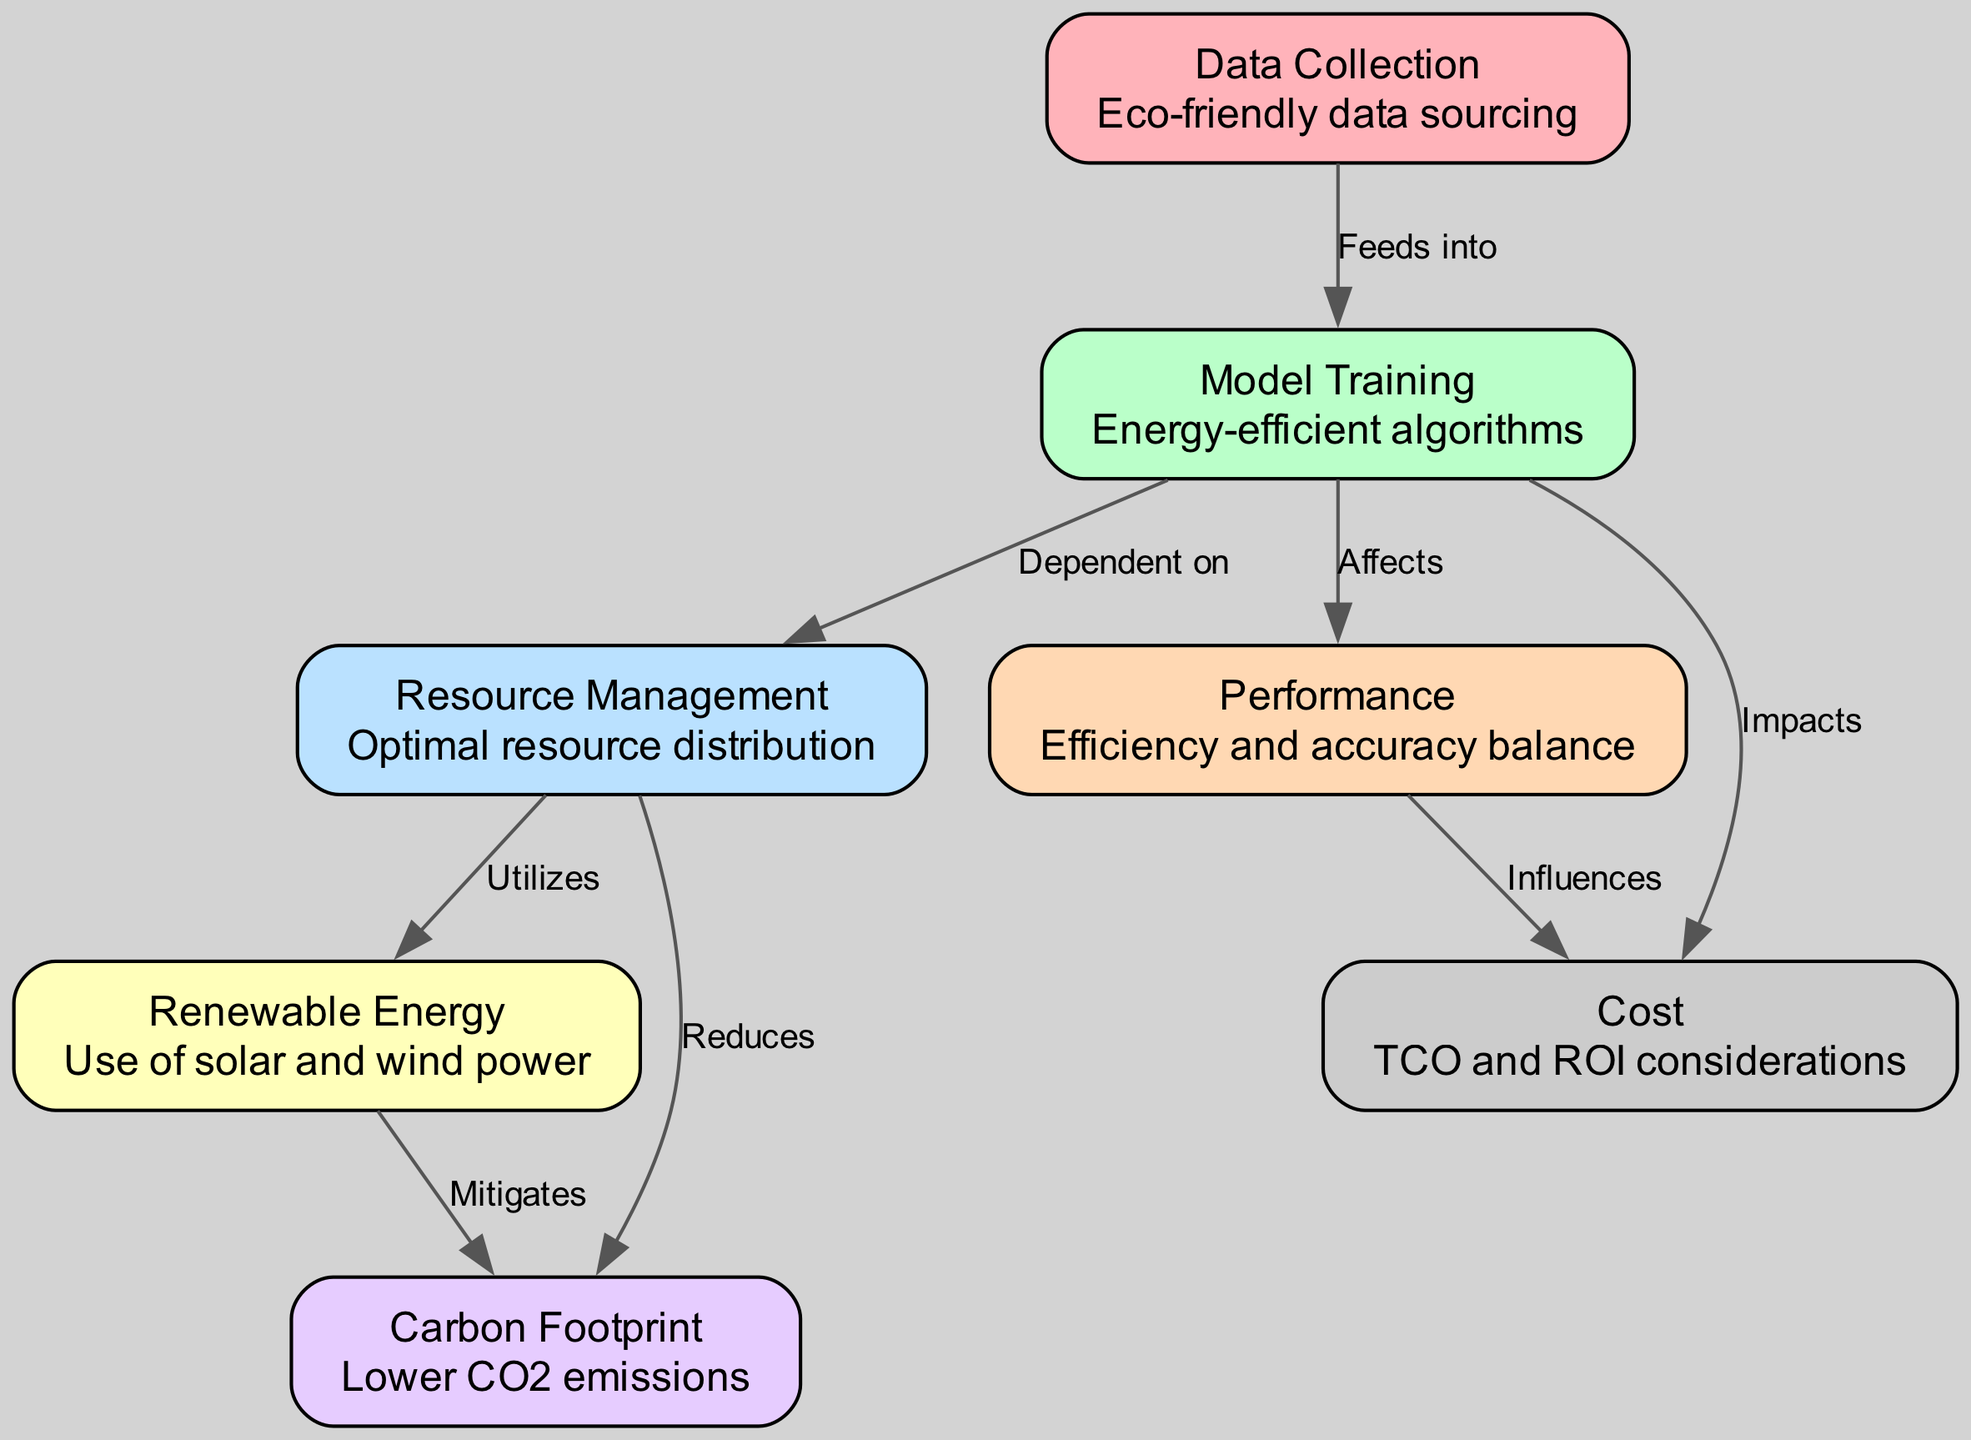What are the main topics covered in the diagram? The diagram lists seven nodes that represent essential aspects of green AI systems: Data Collection, Model Training, Resource Management, Renewable Energy, Carbon Footprint, Performance, and Cost.
Answer: Data Collection, Model Training, Resource Management, Renewable Energy, Carbon Footprint, Performance, Cost How many nodes are in the diagram? The diagram includes a total of seven distinct nodes that contribute to resource allocation and optimization in green AI systems.
Answer: Seven What is the relationship between Model Training and Resource Management? The diagram illustrates that Model Training is dependent on Resource Management, indicating that the efficiency and methods of managing resources directly affect how models are trained.
Answer: Dependent on Which node reduces Carbon Footprint? According to the diagram, Resource Management is shown to have a direct connection that indicates its role in reducing Carbon Footprint through optimal resource allocation.
Answer: Resource Management What impacts the Cost in the diagram? The diagram specifies that Model Training directly impacts Cost, highlighting the significance of the training processes on overall costs in green AI systems.
Answer: Model Training Which energy source is utilized in the Resource Management node? The diagram indicates that Resource Management utilizes Renewable Energy, specifically mentioning the use of solar and wind power for sustainable resource distribution.
Answer: Renewable Energy How do Renewable Energy and Resource Management relate in terms of environmental impact? The diagram shows that Renewable Energy is utilized by Resource Management, which in turn reduces the Carbon Footprint, illustrating a sequence of actions that contribute to environmental sustainability.
Answer: Utilizes What is the main effect of Model Training on Performance? The connection in the diagram indicates that Model Training affects Performance, suggesting that the choice of training methods influences both the efficiency and accuracy of an AI model.
Answer: Affects How does Performance influence Cost in the diagram? The diagram outlines that Performance influences Cost, indicating that improvements or reductions in model performance can have a direct effect on the associated costs of implementing and maintaining the model.
Answer: Influences 